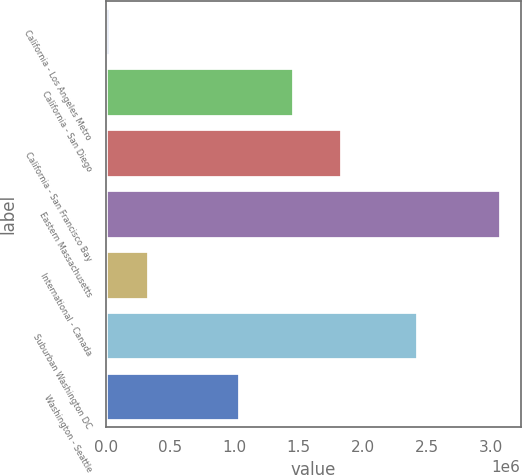Convert chart to OTSL. <chart><loc_0><loc_0><loc_500><loc_500><bar_chart><fcel>California - Los Angeles Metro<fcel>California - San Diego<fcel>California - San Francisco Bay<fcel>Eastern Massachusetts<fcel>International - Canada<fcel>Suburban Washington DC<fcel>Washington - Seattle<nl><fcel>31343<fcel>1.46503e+06<fcel>1.83746e+06<fcel>3.07669e+06<fcel>335878<fcel>2.4304e+06<fcel>1.04011e+06<nl></chart> 